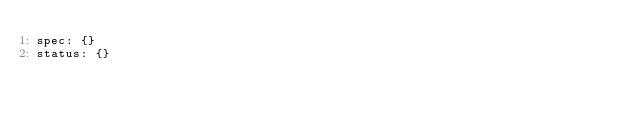Convert code to text. <code><loc_0><loc_0><loc_500><loc_500><_YAML_>spec: {}
status: {}
</code> 